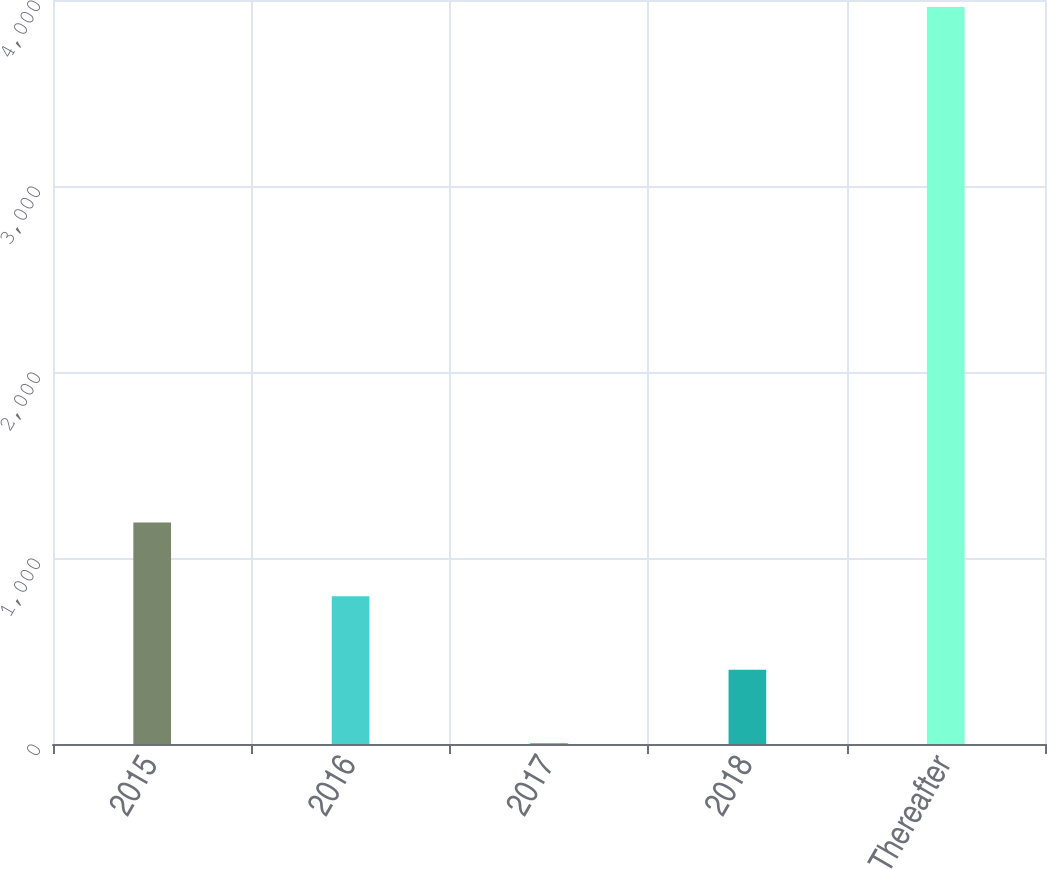Convert chart to OTSL. <chart><loc_0><loc_0><loc_500><loc_500><bar_chart><fcel>2015<fcel>2016<fcel>2017<fcel>2018<fcel>Thereafter<nl><fcel>1190.7<fcel>794.8<fcel>3<fcel>398.9<fcel>3962<nl></chart> 